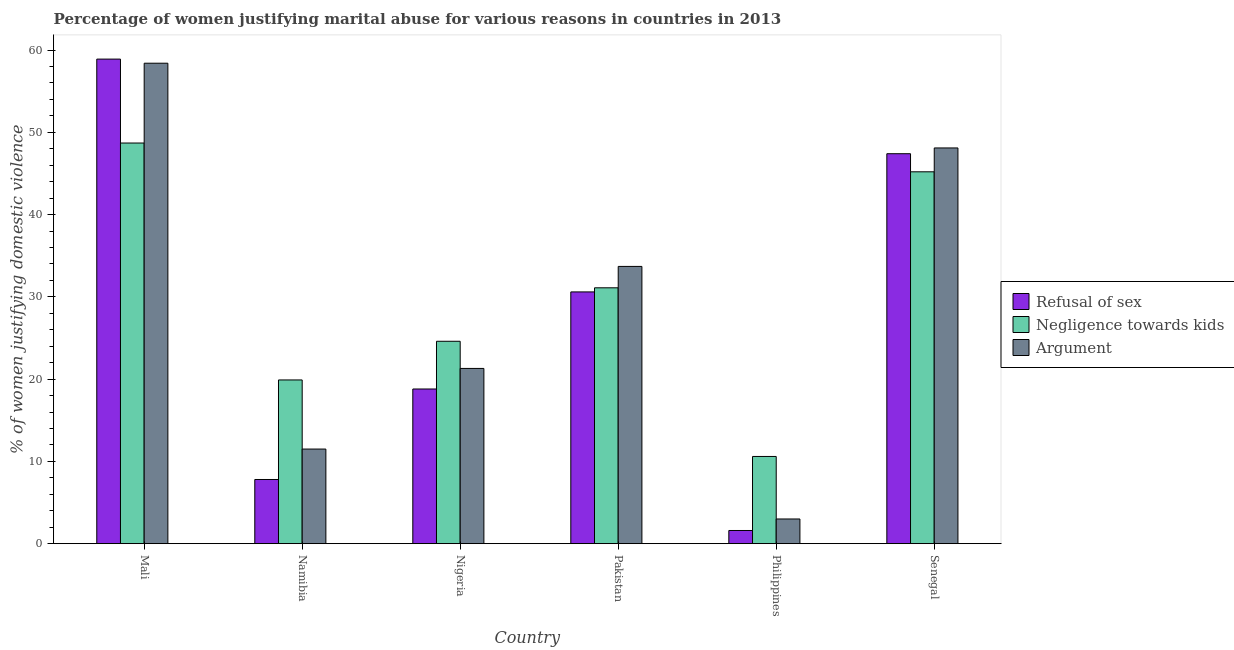How many different coloured bars are there?
Offer a very short reply. 3. How many bars are there on the 4th tick from the left?
Provide a short and direct response. 3. What is the label of the 3rd group of bars from the left?
Give a very brief answer. Nigeria. In how many cases, is the number of bars for a given country not equal to the number of legend labels?
Give a very brief answer. 0. What is the percentage of women justifying domestic violence due to arguments in Nigeria?
Make the answer very short. 21.3. Across all countries, what is the maximum percentage of women justifying domestic violence due to arguments?
Your answer should be compact. 58.4. Across all countries, what is the minimum percentage of women justifying domestic violence due to negligence towards kids?
Provide a succinct answer. 10.6. In which country was the percentage of women justifying domestic violence due to arguments maximum?
Your answer should be very brief. Mali. In which country was the percentage of women justifying domestic violence due to arguments minimum?
Your response must be concise. Philippines. What is the total percentage of women justifying domestic violence due to refusal of sex in the graph?
Make the answer very short. 165.1. What is the difference between the percentage of women justifying domestic violence due to negligence towards kids in Philippines and the percentage of women justifying domestic violence due to arguments in Namibia?
Your answer should be compact. -0.9. What is the average percentage of women justifying domestic violence due to refusal of sex per country?
Keep it short and to the point. 27.52. What is the difference between the percentage of women justifying domestic violence due to negligence towards kids and percentage of women justifying domestic violence due to refusal of sex in Senegal?
Give a very brief answer. -2.2. What is the ratio of the percentage of women justifying domestic violence due to negligence towards kids in Mali to that in Pakistan?
Offer a terse response. 1.57. Is the difference between the percentage of women justifying domestic violence due to arguments in Nigeria and Pakistan greater than the difference between the percentage of women justifying domestic violence due to negligence towards kids in Nigeria and Pakistan?
Ensure brevity in your answer.  No. What is the difference between the highest and the lowest percentage of women justifying domestic violence due to arguments?
Ensure brevity in your answer.  55.4. Is the sum of the percentage of women justifying domestic violence due to arguments in Mali and Senegal greater than the maximum percentage of women justifying domestic violence due to refusal of sex across all countries?
Your response must be concise. Yes. What does the 1st bar from the left in Mali represents?
Offer a terse response. Refusal of sex. What does the 1st bar from the right in Senegal represents?
Offer a terse response. Argument. Is it the case that in every country, the sum of the percentage of women justifying domestic violence due to refusal of sex and percentage of women justifying domestic violence due to negligence towards kids is greater than the percentage of women justifying domestic violence due to arguments?
Make the answer very short. Yes. How many countries are there in the graph?
Ensure brevity in your answer.  6. Are the values on the major ticks of Y-axis written in scientific E-notation?
Give a very brief answer. No. Does the graph contain any zero values?
Offer a terse response. No. How many legend labels are there?
Your response must be concise. 3. How are the legend labels stacked?
Provide a short and direct response. Vertical. What is the title of the graph?
Offer a terse response. Percentage of women justifying marital abuse for various reasons in countries in 2013. Does "Interest" appear as one of the legend labels in the graph?
Your answer should be compact. No. What is the label or title of the Y-axis?
Your answer should be very brief. % of women justifying domestic violence. What is the % of women justifying domestic violence of Refusal of sex in Mali?
Your answer should be compact. 58.9. What is the % of women justifying domestic violence of Negligence towards kids in Mali?
Keep it short and to the point. 48.7. What is the % of women justifying domestic violence in Argument in Mali?
Ensure brevity in your answer.  58.4. What is the % of women justifying domestic violence of Refusal of sex in Namibia?
Offer a very short reply. 7.8. What is the % of women justifying domestic violence of Negligence towards kids in Namibia?
Provide a succinct answer. 19.9. What is the % of women justifying domestic violence of Negligence towards kids in Nigeria?
Provide a succinct answer. 24.6. What is the % of women justifying domestic violence of Argument in Nigeria?
Give a very brief answer. 21.3. What is the % of women justifying domestic violence in Refusal of sex in Pakistan?
Give a very brief answer. 30.6. What is the % of women justifying domestic violence in Negligence towards kids in Pakistan?
Your response must be concise. 31.1. What is the % of women justifying domestic violence in Argument in Pakistan?
Keep it short and to the point. 33.7. What is the % of women justifying domestic violence in Refusal of sex in Philippines?
Make the answer very short. 1.6. What is the % of women justifying domestic violence of Argument in Philippines?
Provide a short and direct response. 3. What is the % of women justifying domestic violence of Refusal of sex in Senegal?
Offer a terse response. 47.4. What is the % of women justifying domestic violence of Negligence towards kids in Senegal?
Your response must be concise. 45.2. What is the % of women justifying domestic violence of Argument in Senegal?
Your response must be concise. 48.1. Across all countries, what is the maximum % of women justifying domestic violence in Refusal of sex?
Provide a short and direct response. 58.9. Across all countries, what is the maximum % of women justifying domestic violence in Negligence towards kids?
Offer a terse response. 48.7. Across all countries, what is the maximum % of women justifying domestic violence of Argument?
Keep it short and to the point. 58.4. Across all countries, what is the minimum % of women justifying domestic violence of Refusal of sex?
Ensure brevity in your answer.  1.6. Across all countries, what is the minimum % of women justifying domestic violence of Negligence towards kids?
Give a very brief answer. 10.6. Across all countries, what is the minimum % of women justifying domestic violence in Argument?
Offer a terse response. 3. What is the total % of women justifying domestic violence in Refusal of sex in the graph?
Provide a succinct answer. 165.1. What is the total % of women justifying domestic violence in Negligence towards kids in the graph?
Ensure brevity in your answer.  180.1. What is the total % of women justifying domestic violence of Argument in the graph?
Keep it short and to the point. 176. What is the difference between the % of women justifying domestic violence of Refusal of sex in Mali and that in Namibia?
Provide a succinct answer. 51.1. What is the difference between the % of women justifying domestic violence in Negligence towards kids in Mali and that in Namibia?
Provide a succinct answer. 28.8. What is the difference between the % of women justifying domestic violence of Argument in Mali and that in Namibia?
Offer a very short reply. 46.9. What is the difference between the % of women justifying domestic violence of Refusal of sex in Mali and that in Nigeria?
Your response must be concise. 40.1. What is the difference between the % of women justifying domestic violence in Negligence towards kids in Mali and that in Nigeria?
Your answer should be very brief. 24.1. What is the difference between the % of women justifying domestic violence in Argument in Mali and that in Nigeria?
Ensure brevity in your answer.  37.1. What is the difference between the % of women justifying domestic violence in Refusal of sex in Mali and that in Pakistan?
Make the answer very short. 28.3. What is the difference between the % of women justifying domestic violence of Negligence towards kids in Mali and that in Pakistan?
Provide a succinct answer. 17.6. What is the difference between the % of women justifying domestic violence of Argument in Mali and that in Pakistan?
Keep it short and to the point. 24.7. What is the difference between the % of women justifying domestic violence of Refusal of sex in Mali and that in Philippines?
Give a very brief answer. 57.3. What is the difference between the % of women justifying domestic violence in Negligence towards kids in Mali and that in Philippines?
Your answer should be very brief. 38.1. What is the difference between the % of women justifying domestic violence in Argument in Mali and that in Philippines?
Give a very brief answer. 55.4. What is the difference between the % of women justifying domestic violence in Negligence towards kids in Mali and that in Senegal?
Your response must be concise. 3.5. What is the difference between the % of women justifying domestic violence of Argument in Mali and that in Senegal?
Ensure brevity in your answer.  10.3. What is the difference between the % of women justifying domestic violence of Refusal of sex in Namibia and that in Pakistan?
Make the answer very short. -22.8. What is the difference between the % of women justifying domestic violence in Argument in Namibia and that in Pakistan?
Give a very brief answer. -22.2. What is the difference between the % of women justifying domestic violence in Refusal of sex in Namibia and that in Philippines?
Ensure brevity in your answer.  6.2. What is the difference between the % of women justifying domestic violence of Negligence towards kids in Namibia and that in Philippines?
Your response must be concise. 9.3. What is the difference between the % of women justifying domestic violence of Argument in Namibia and that in Philippines?
Your answer should be very brief. 8.5. What is the difference between the % of women justifying domestic violence in Refusal of sex in Namibia and that in Senegal?
Provide a succinct answer. -39.6. What is the difference between the % of women justifying domestic violence in Negligence towards kids in Namibia and that in Senegal?
Offer a very short reply. -25.3. What is the difference between the % of women justifying domestic violence of Argument in Namibia and that in Senegal?
Keep it short and to the point. -36.6. What is the difference between the % of women justifying domestic violence of Refusal of sex in Nigeria and that in Pakistan?
Your answer should be compact. -11.8. What is the difference between the % of women justifying domestic violence of Argument in Nigeria and that in Pakistan?
Your answer should be compact. -12.4. What is the difference between the % of women justifying domestic violence in Negligence towards kids in Nigeria and that in Philippines?
Provide a short and direct response. 14. What is the difference between the % of women justifying domestic violence of Argument in Nigeria and that in Philippines?
Keep it short and to the point. 18.3. What is the difference between the % of women justifying domestic violence of Refusal of sex in Nigeria and that in Senegal?
Your answer should be very brief. -28.6. What is the difference between the % of women justifying domestic violence of Negligence towards kids in Nigeria and that in Senegal?
Offer a very short reply. -20.6. What is the difference between the % of women justifying domestic violence in Argument in Nigeria and that in Senegal?
Keep it short and to the point. -26.8. What is the difference between the % of women justifying domestic violence of Negligence towards kids in Pakistan and that in Philippines?
Provide a succinct answer. 20.5. What is the difference between the % of women justifying domestic violence of Argument in Pakistan and that in Philippines?
Make the answer very short. 30.7. What is the difference between the % of women justifying domestic violence of Refusal of sex in Pakistan and that in Senegal?
Your answer should be compact. -16.8. What is the difference between the % of women justifying domestic violence of Negligence towards kids in Pakistan and that in Senegal?
Provide a succinct answer. -14.1. What is the difference between the % of women justifying domestic violence in Argument in Pakistan and that in Senegal?
Provide a short and direct response. -14.4. What is the difference between the % of women justifying domestic violence of Refusal of sex in Philippines and that in Senegal?
Provide a succinct answer. -45.8. What is the difference between the % of women justifying domestic violence of Negligence towards kids in Philippines and that in Senegal?
Provide a short and direct response. -34.6. What is the difference between the % of women justifying domestic violence of Argument in Philippines and that in Senegal?
Offer a terse response. -45.1. What is the difference between the % of women justifying domestic violence of Refusal of sex in Mali and the % of women justifying domestic violence of Argument in Namibia?
Your response must be concise. 47.4. What is the difference between the % of women justifying domestic violence of Negligence towards kids in Mali and the % of women justifying domestic violence of Argument in Namibia?
Offer a very short reply. 37.2. What is the difference between the % of women justifying domestic violence in Refusal of sex in Mali and the % of women justifying domestic violence in Negligence towards kids in Nigeria?
Your answer should be very brief. 34.3. What is the difference between the % of women justifying domestic violence in Refusal of sex in Mali and the % of women justifying domestic violence in Argument in Nigeria?
Your answer should be compact. 37.6. What is the difference between the % of women justifying domestic violence in Negligence towards kids in Mali and the % of women justifying domestic violence in Argument in Nigeria?
Offer a terse response. 27.4. What is the difference between the % of women justifying domestic violence in Refusal of sex in Mali and the % of women justifying domestic violence in Negligence towards kids in Pakistan?
Your answer should be compact. 27.8. What is the difference between the % of women justifying domestic violence in Refusal of sex in Mali and the % of women justifying domestic violence in Argument in Pakistan?
Your answer should be very brief. 25.2. What is the difference between the % of women justifying domestic violence in Refusal of sex in Mali and the % of women justifying domestic violence in Negligence towards kids in Philippines?
Offer a very short reply. 48.3. What is the difference between the % of women justifying domestic violence in Refusal of sex in Mali and the % of women justifying domestic violence in Argument in Philippines?
Your answer should be very brief. 55.9. What is the difference between the % of women justifying domestic violence of Negligence towards kids in Mali and the % of women justifying domestic violence of Argument in Philippines?
Provide a short and direct response. 45.7. What is the difference between the % of women justifying domestic violence of Refusal of sex in Mali and the % of women justifying domestic violence of Negligence towards kids in Senegal?
Your answer should be compact. 13.7. What is the difference between the % of women justifying domestic violence in Refusal of sex in Namibia and the % of women justifying domestic violence in Negligence towards kids in Nigeria?
Offer a terse response. -16.8. What is the difference between the % of women justifying domestic violence of Negligence towards kids in Namibia and the % of women justifying domestic violence of Argument in Nigeria?
Offer a terse response. -1.4. What is the difference between the % of women justifying domestic violence of Refusal of sex in Namibia and the % of women justifying domestic violence of Negligence towards kids in Pakistan?
Your answer should be compact. -23.3. What is the difference between the % of women justifying domestic violence of Refusal of sex in Namibia and the % of women justifying domestic violence of Argument in Pakistan?
Give a very brief answer. -25.9. What is the difference between the % of women justifying domestic violence in Negligence towards kids in Namibia and the % of women justifying domestic violence in Argument in Pakistan?
Your response must be concise. -13.8. What is the difference between the % of women justifying domestic violence in Refusal of sex in Namibia and the % of women justifying domestic violence in Negligence towards kids in Philippines?
Your answer should be very brief. -2.8. What is the difference between the % of women justifying domestic violence of Negligence towards kids in Namibia and the % of women justifying domestic violence of Argument in Philippines?
Offer a terse response. 16.9. What is the difference between the % of women justifying domestic violence in Refusal of sex in Namibia and the % of women justifying domestic violence in Negligence towards kids in Senegal?
Your answer should be very brief. -37.4. What is the difference between the % of women justifying domestic violence of Refusal of sex in Namibia and the % of women justifying domestic violence of Argument in Senegal?
Give a very brief answer. -40.3. What is the difference between the % of women justifying domestic violence in Negligence towards kids in Namibia and the % of women justifying domestic violence in Argument in Senegal?
Offer a terse response. -28.2. What is the difference between the % of women justifying domestic violence of Refusal of sex in Nigeria and the % of women justifying domestic violence of Negligence towards kids in Pakistan?
Offer a very short reply. -12.3. What is the difference between the % of women justifying domestic violence of Refusal of sex in Nigeria and the % of women justifying domestic violence of Argument in Pakistan?
Provide a short and direct response. -14.9. What is the difference between the % of women justifying domestic violence in Refusal of sex in Nigeria and the % of women justifying domestic violence in Negligence towards kids in Philippines?
Make the answer very short. 8.2. What is the difference between the % of women justifying domestic violence in Negligence towards kids in Nigeria and the % of women justifying domestic violence in Argument in Philippines?
Your answer should be compact. 21.6. What is the difference between the % of women justifying domestic violence of Refusal of sex in Nigeria and the % of women justifying domestic violence of Negligence towards kids in Senegal?
Give a very brief answer. -26.4. What is the difference between the % of women justifying domestic violence in Refusal of sex in Nigeria and the % of women justifying domestic violence in Argument in Senegal?
Your response must be concise. -29.3. What is the difference between the % of women justifying domestic violence of Negligence towards kids in Nigeria and the % of women justifying domestic violence of Argument in Senegal?
Make the answer very short. -23.5. What is the difference between the % of women justifying domestic violence in Refusal of sex in Pakistan and the % of women justifying domestic violence in Argument in Philippines?
Keep it short and to the point. 27.6. What is the difference between the % of women justifying domestic violence in Negligence towards kids in Pakistan and the % of women justifying domestic violence in Argument in Philippines?
Provide a succinct answer. 28.1. What is the difference between the % of women justifying domestic violence in Refusal of sex in Pakistan and the % of women justifying domestic violence in Negligence towards kids in Senegal?
Ensure brevity in your answer.  -14.6. What is the difference between the % of women justifying domestic violence in Refusal of sex in Pakistan and the % of women justifying domestic violence in Argument in Senegal?
Ensure brevity in your answer.  -17.5. What is the difference between the % of women justifying domestic violence in Refusal of sex in Philippines and the % of women justifying domestic violence in Negligence towards kids in Senegal?
Ensure brevity in your answer.  -43.6. What is the difference between the % of women justifying domestic violence in Refusal of sex in Philippines and the % of women justifying domestic violence in Argument in Senegal?
Provide a succinct answer. -46.5. What is the difference between the % of women justifying domestic violence in Negligence towards kids in Philippines and the % of women justifying domestic violence in Argument in Senegal?
Make the answer very short. -37.5. What is the average % of women justifying domestic violence in Refusal of sex per country?
Ensure brevity in your answer.  27.52. What is the average % of women justifying domestic violence of Negligence towards kids per country?
Your answer should be very brief. 30.02. What is the average % of women justifying domestic violence of Argument per country?
Make the answer very short. 29.33. What is the difference between the % of women justifying domestic violence of Refusal of sex and % of women justifying domestic violence of Negligence towards kids in Mali?
Offer a terse response. 10.2. What is the difference between the % of women justifying domestic violence in Refusal of sex and % of women justifying domestic violence in Negligence towards kids in Namibia?
Give a very brief answer. -12.1. What is the difference between the % of women justifying domestic violence of Negligence towards kids and % of women justifying domestic violence of Argument in Namibia?
Keep it short and to the point. 8.4. What is the difference between the % of women justifying domestic violence of Refusal of sex and % of women justifying domestic violence of Negligence towards kids in Nigeria?
Offer a very short reply. -5.8. What is the difference between the % of women justifying domestic violence of Negligence towards kids and % of women justifying domestic violence of Argument in Nigeria?
Your answer should be compact. 3.3. What is the difference between the % of women justifying domestic violence of Refusal of sex and % of women justifying domestic violence of Argument in Pakistan?
Provide a succinct answer. -3.1. What is the difference between the % of women justifying domestic violence in Negligence towards kids and % of women justifying domestic violence in Argument in Pakistan?
Offer a terse response. -2.6. What is the difference between the % of women justifying domestic violence in Refusal of sex and % of women justifying domestic violence in Negligence towards kids in Philippines?
Keep it short and to the point. -9. What is the difference between the % of women justifying domestic violence of Refusal of sex and % of women justifying domestic violence of Argument in Philippines?
Your answer should be compact. -1.4. What is the difference between the % of women justifying domestic violence of Negligence towards kids and % of women justifying domestic violence of Argument in Philippines?
Ensure brevity in your answer.  7.6. What is the difference between the % of women justifying domestic violence in Refusal of sex and % of women justifying domestic violence in Negligence towards kids in Senegal?
Offer a very short reply. 2.2. What is the difference between the % of women justifying domestic violence in Refusal of sex and % of women justifying domestic violence in Argument in Senegal?
Keep it short and to the point. -0.7. What is the difference between the % of women justifying domestic violence of Negligence towards kids and % of women justifying domestic violence of Argument in Senegal?
Keep it short and to the point. -2.9. What is the ratio of the % of women justifying domestic violence in Refusal of sex in Mali to that in Namibia?
Offer a terse response. 7.55. What is the ratio of the % of women justifying domestic violence in Negligence towards kids in Mali to that in Namibia?
Offer a terse response. 2.45. What is the ratio of the % of women justifying domestic violence of Argument in Mali to that in Namibia?
Ensure brevity in your answer.  5.08. What is the ratio of the % of women justifying domestic violence in Refusal of sex in Mali to that in Nigeria?
Give a very brief answer. 3.13. What is the ratio of the % of women justifying domestic violence in Negligence towards kids in Mali to that in Nigeria?
Make the answer very short. 1.98. What is the ratio of the % of women justifying domestic violence in Argument in Mali to that in Nigeria?
Provide a succinct answer. 2.74. What is the ratio of the % of women justifying domestic violence in Refusal of sex in Mali to that in Pakistan?
Make the answer very short. 1.92. What is the ratio of the % of women justifying domestic violence in Negligence towards kids in Mali to that in Pakistan?
Offer a terse response. 1.57. What is the ratio of the % of women justifying domestic violence of Argument in Mali to that in Pakistan?
Your answer should be very brief. 1.73. What is the ratio of the % of women justifying domestic violence of Refusal of sex in Mali to that in Philippines?
Provide a succinct answer. 36.81. What is the ratio of the % of women justifying domestic violence in Negligence towards kids in Mali to that in Philippines?
Your answer should be compact. 4.59. What is the ratio of the % of women justifying domestic violence in Argument in Mali to that in Philippines?
Offer a very short reply. 19.47. What is the ratio of the % of women justifying domestic violence in Refusal of sex in Mali to that in Senegal?
Your response must be concise. 1.24. What is the ratio of the % of women justifying domestic violence of Negligence towards kids in Mali to that in Senegal?
Offer a terse response. 1.08. What is the ratio of the % of women justifying domestic violence in Argument in Mali to that in Senegal?
Provide a short and direct response. 1.21. What is the ratio of the % of women justifying domestic violence in Refusal of sex in Namibia to that in Nigeria?
Provide a short and direct response. 0.41. What is the ratio of the % of women justifying domestic violence of Negligence towards kids in Namibia to that in Nigeria?
Your answer should be compact. 0.81. What is the ratio of the % of women justifying domestic violence in Argument in Namibia to that in Nigeria?
Your response must be concise. 0.54. What is the ratio of the % of women justifying domestic violence in Refusal of sex in Namibia to that in Pakistan?
Your answer should be compact. 0.25. What is the ratio of the % of women justifying domestic violence of Negligence towards kids in Namibia to that in Pakistan?
Your answer should be compact. 0.64. What is the ratio of the % of women justifying domestic violence of Argument in Namibia to that in Pakistan?
Provide a succinct answer. 0.34. What is the ratio of the % of women justifying domestic violence in Refusal of sex in Namibia to that in Philippines?
Your response must be concise. 4.88. What is the ratio of the % of women justifying domestic violence in Negligence towards kids in Namibia to that in Philippines?
Offer a very short reply. 1.88. What is the ratio of the % of women justifying domestic violence in Argument in Namibia to that in Philippines?
Your answer should be very brief. 3.83. What is the ratio of the % of women justifying domestic violence of Refusal of sex in Namibia to that in Senegal?
Your answer should be compact. 0.16. What is the ratio of the % of women justifying domestic violence in Negligence towards kids in Namibia to that in Senegal?
Offer a terse response. 0.44. What is the ratio of the % of women justifying domestic violence in Argument in Namibia to that in Senegal?
Make the answer very short. 0.24. What is the ratio of the % of women justifying domestic violence in Refusal of sex in Nigeria to that in Pakistan?
Ensure brevity in your answer.  0.61. What is the ratio of the % of women justifying domestic violence of Negligence towards kids in Nigeria to that in Pakistan?
Offer a very short reply. 0.79. What is the ratio of the % of women justifying domestic violence in Argument in Nigeria to that in Pakistan?
Make the answer very short. 0.63. What is the ratio of the % of women justifying domestic violence of Refusal of sex in Nigeria to that in Philippines?
Give a very brief answer. 11.75. What is the ratio of the % of women justifying domestic violence of Negligence towards kids in Nigeria to that in Philippines?
Your answer should be compact. 2.32. What is the ratio of the % of women justifying domestic violence of Refusal of sex in Nigeria to that in Senegal?
Offer a terse response. 0.4. What is the ratio of the % of women justifying domestic violence in Negligence towards kids in Nigeria to that in Senegal?
Provide a succinct answer. 0.54. What is the ratio of the % of women justifying domestic violence of Argument in Nigeria to that in Senegal?
Your response must be concise. 0.44. What is the ratio of the % of women justifying domestic violence of Refusal of sex in Pakistan to that in Philippines?
Offer a very short reply. 19.12. What is the ratio of the % of women justifying domestic violence in Negligence towards kids in Pakistan to that in Philippines?
Offer a terse response. 2.93. What is the ratio of the % of women justifying domestic violence in Argument in Pakistan to that in Philippines?
Your answer should be compact. 11.23. What is the ratio of the % of women justifying domestic violence of Refusal of sex in Pakistan to that in Senegal?
Give a very brief answer. 0.65. What is the ratio of the % of women justifying domestic violence in Negligence towards kids in Pakistan to that in Senegal?
Give a very brief answer. 0.69. What is the ratio of the % of women justifying domestic violence in Argument in Pakistan to that in Senegal?
Ensure brevity in your answer.  0.7. What is the ratio of the % of women justifying domestic violence of Refusal of sex in Philippines to that in Senegal?
Make the answer very short. 0.03. What is the ratio of the % of women justifying domestic violence of Negligence towards kids in Philippines to that in Senegal?
Your answer should be very brief. 0.23. What is the ratio of the % of women justifying domestic violence of Argument in Philippines to that in Senegal?
Offer a terse response. 0.06. What is the difference between the highest and the lowest % of women justifying domestic violence of Refusal of sex?
Provide a succinct answer. 57.3. What is the difference between the highest and the lowest % of women justifying domestic violence of Negligence towards kids?
Give a very brief answer. 38.1. What is the difference between the highest and the lowest % of women justifying domestic violence in Argument?
Provide a short and direct response. 55.4. 